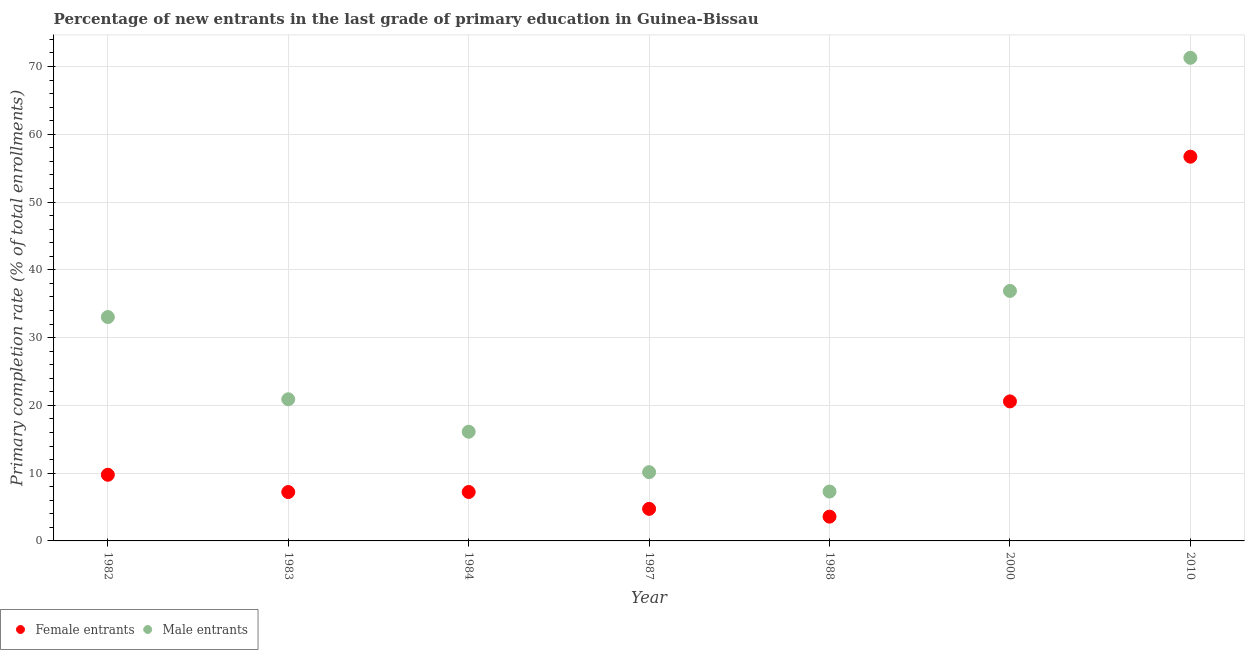How many different coloured dotlines are there?
Offer a very short reply. 2. What is the primary completion rate of female entrants in 1988?
Ensure brevity in your answer.  3.58. Across all years, what is the maximum primary completion rate of female entrants?
Offer a very short reply. 56.69. Across all years, what is the minimum primary completion rate of male entrants?
Your answer should be very brief. 7.28. What is the total primary completion rate of female entrants in the graph?
Keep it short and to the point. 109.78. What is the difference between the primary completion rate of female entrants in 1983 and that in 1988?
Ensure brevity in your answer.  3.63. What is the difference between the primary completion rate of male entrants in 1982 and the primary completion rate of female entrants in 1984?
Provide a succinct answer. 25.81. What is the average primary completion rate of female entrants per year?
Your answer should be compact. 15.68. In the year 1988, what is the difference between the primary completion rate of male entrants and primary completion rate of female entrants?
Provide a short and direct response. 3.7. In how many years, is the primary completion rate of male entrants greater than 58 %?
Keep it short and to the point. 1. What is the ratio of the primary completion rate of female entrants in 1983 to that in 1987?
Offer a terse response. 1.52. What is the difference between the highest and the second highest primary completion rate of male entrants?
Provide a short and direct response. 34.39. What is the difference between the highest and the lowest primary completion rate of male entrants?
Give a very brief answer. 63.99. Is the sum of the primary completion rate of female entrants in 1987 and 2000 greater than the maximum primary completion rate of male entrants across all years?
Provide a succinct answer. No. Is the primary completion rate of female entrants strictly less than the primary completion rate of male entrants over the years?
Keep it short and to the point. Yes. How many years are there in the graph?
Provide a succinct answer. 7. What is the difference between two consecutive major ticks on the Y-axis?
Provide a short and direct response. 10. Are the values on the major ticks of Y-axis written in scientific E-notation?
Provide a succinct answer. No. Does the graph contain grids?
Offer a terse response. Yes. Where does the legend appear in the graph?
Provide a succinct answer. Bottom left. How many legend labels are there?
Ensure brevity in your answer.  2. What is the title of the graph?
Provide a succinct answer. Percentage of new entrants in the last grade of primary education in Guinea-Bissau. What is the label or title of the X-axis?
Ensure brevity in your answer.  Year. What is the label or title of the Y-axis?
Give a very brief answer. Primary completion rate (% of total enrollments). What is the Primary completion rate (% of total enrollments) in Female entrants in 1982?
Your answer should be very brief. 9.76. What is the Primary completion rate (% of total enrollments) of Male entrants in 1982?
Ensure brevity in your answer.  33.03. What is the Primary completion rate (% of total enrollments) in Female entrants in 1983?
Ensure brevity in your answer.  7.21. What is the Primary completion rate (% of total enrollments) of Male entrants in 1983?
Your answer should be very brief. 20.9. What is the Primary completion rate (% of total enrollments) in Female entrants in 1984?
Ensure brevity in your answer.  7.22. What is the Primary completion rate (% of total enrollments) in Male entrants in 1984?
Offer a terse response. 16.11. What is the Primary completion rate (% of total enrollments) of Female entrants in 1987?
Keep it short and to the point. 4.73. What is the Primary completion rate (% of total enrollments) in Male entrants in 1987?
Offer a terse response. 10.14. What is the Primary completion rate (% of total enrollments) of Female entrants in 1988?
Your answer should be very brief. 3.58. What is the Primary completion rate (% of total enrollments) in Male entrants in 1988?
Provide a succinct answer. 7.28. What is the Primary completion rate (% of total enrollments) of Female entrants in 2000?
Give a very brief answer. 20.58. What is the Primary completion rate (% of total enrollments) of Male entrants in 2000?
Ensure brevity in your answer.  36.88. What is the Primary completion rate (% of total enrollments) in Female entrants in 2010?
Keep it short and to the point. 56.69. What is the Primary completion rate (% of total enrollments) of Male entrants in 2010?
Provide a succinct answer. 71.27. Across all years, what is the maximum Primary completion rate (% of total enrollments) in Female entrants?
Offer a terse response. 56.69. Across all years, what is the maximum Primary completion rate (% of total enrollments) of Male entrants?
Keep it short and to the point. 71.27. Across all years, what is the minimum Primary completion rate (% of total enrollments) of Female entrants?
Provide a succinct answer. 3.58. Across all years, what is the minimum Primary completion rate (% of total enrollments) of Male entrants?
Your answer should be very brief. 7.28. What is the total Primary completion rate (% of total enrollments) in Female entrants in the graph?
Your response must be concise. 109.78. What is the total Primary completion rate (% of total enrollments) of Male entrants in the graph?
Give a very brief answer. 195.62. What is the difference between the Primary completion rate (% of total enrollments) in Female entrants in 1982 and that in 1983?
Provide a succinct answer. 2.55. What is the difference between the Primary completion rate (% of total enrollments) in Male entrants in 1982 and that in 1983?
Ensure brevity in your answer.  12.13. What is the difference between the Primary completion rate (% of total enrollments) in Female entrants in 1982 and that in 1984?
Offer a terse response. 2.54. What is the difference between the Primary completion rate (% of total enrollments) of Male entrants in 1982 and that in 1984?
Offer a terse response. 16.92. What is the difference between the Primary completion rate (% of total enrollments) in Female entrants in 1982 and that in 1987?
Make the answer very short. 5.03. What is the difference between the Primary completion rate (% of total enrollments) in Male entrants in 1982 and that in 1987?
Offer a very short reply. 22.89. What is the difference between the Primary completion rate (% of total enrollments) of Female entrants in 1982 and that in 1988?
Your answer should be compact. 6.18. What is the difference between the Primary completion rate (% of total enrollments) in Male entrants in 1982 and that in 1988?
Make the answer very short. 25.74. What is the difference between the Primary completion rate (% of total enrollments) in Female entrants in 1982 and that in 2000?
Make the answer very short. -10.82. What is the difference between the Primary completion rate (% of total enrollments) in Male entrants in 1982 and that in 2000?
Keep it short and to the point. -3.86. What is the difference between the Primary completion rate (% of total enrollments) in Female entrants in 1982 and that in 2010?
Provide a succinct answer. -46.93. What is the difference between the Primary completion rate (% of total enrollments) in Male entrants in 1982 and that in 2010?
Provide a short and direct response. -38.25. What is the difference between the Primary completion rate (% of total enrollments) of Female entrants in 1983 and that in 1984?
Your answer should be compact. -0.01. What is the difference between the Primary completion rate (% of total enrollments) of Male entrants in 1983 and that in 1984?
Make the answer very short. 4.79. What is the difference between the Primary completion rate (% of total enrollments) in Female entrants in 1983 and that in 1987?
Your answer should be compact. 2.48. What is the difference between the Primary completion rate (% of total enrollments) in Male entrants in 1983 and that in 1987?
Provide a succinct answer. 10.76. What is the difference between the Primary completion rate (% of total enrollments) of Female entrants in 1983 and that in 1988?
Give a very brief answer. 3.63. What is the difference between the Primary completion rate (% of total enrollments) in Male entrants in 1983 and that in 1988?
Your answer should be very brief. 13.61. What is the difference between the Primary completion rate (% of total enrollments) in Female entrants in 1983 and that in 2000?
Provide a short and direct response. -13.37. What is the difference between the Primary completion rate (% of total enrollments) of Male entrants in 1983 and that in 2000?
Provide a short and direct response. -15.99. What is the difference between the Primary completion rate (% of total enrollments) of Female entrants in 1983 and that in 2010?
Keep it short and to the point. -49.48. What is the difference between the Primary completion rate (% of total enrollments) in Male entrants in 1983 and that in 2010?
Ensure brevity in your answer.  -50.38. What is the difference between the Primary completion rate (% of total enrollments) of Female entrants in 1984 and that in 1987?
Your answer should be compact. 2.49. What is the difference between the Primary completion rate (% of total enrollments) of Male entrants in 1984 and that in 1987?
Offer a very short reply. 5.97. What is the difference between the Primary completion rate (% of total enrollments) of Female entrants in 1984 and that in 1988?
Give a very brief answer. 3.64. What is the difference between the Primary completion rate (% of total enrollments) of Male entrants in 1984 and that in 1988?
Ensure brevity in your answer.  8.82. What is the difference between the Primary completion rate (% of total enrollments) in Female entrants in 1984 and that in 2000?
Give a very brief answer. -13.37. What is the difference between the Primary completion rate (% of total enrollments) in Male entrants in 1984 and that in 2000?
Ensure brevity in your answer.  -20.78. What is the difference between the Primary completion rate (% of total enrollments) in Female entrants in 1984 and that in 2010?
Ensure brevity in your answer.  -49.47. What is the difference between the Primary completion rate (% of total enrollments) in Male entrants in 1984 and that in 2010?
Offer a terse response. -55.17. What is the difference between the Primary completion rate (% of total enrollments) in Female entrants in 1987 and that in 1988?
Provide a short and direct response. 1.15. What is the difference between the Primary completion rate (% of total enrollments) in Male entrants in 1987 and that in 1988?
Your response must be concise. 2.86. What is the difference between the Primary completion rate (% of total enrollments) in Female entrants in 1987 and that in 2000?
Provide a succinct answer. -15.85. What is the difference between the Primary completion rate (% of total enrollments) in Male entrants in 1987 and that in 2000?
Keep it short and to the point. -26.74. What is the difference between the Primary completion rate (% of total enrollments) in Female entrants in 1987 and that in 2010?
Your response must be concise. -51.96. What is the difference between the Primary completion rate (% of total enrollments) in Male entrants in 1987 and that in 2010?
Give a very brief answer. -61.13. What is the difference between the Primary completion rate (% of total enrollments) of Female entrants in 1988 and that in 2000?
Offer a very short reply. -17. What is the difference between the Primary completion rate (% of total enrollments) in Male entrants in 1988 and that in 2000?
Give a very brief answer. -29.6. What is the difference between the Primary completion rate (% of total enrollments) of Female entrants in 1988 and that in 2010?
Your answer should be compact. -53.11. What is the difference between the Primary completion rate (% of total enrollments) in Male entrants in 1988 and that in 2010?
Your answer should be very brief. -63.99. What is the difference between the Primary completion rate (% of total enrollments) of Female entrants in 2000 and that in 2010?
Your response must be concise. -36.1. What is the difference between the Primary completion rate (% of total enrollments) of Male entrants in 2000 and that in 2010?
Provide a succinct answer. -34.39. What is the difference between the Primary completion rate (% of total enrollments) of Female entrants in 1982 and the Primary completion rate (% of total enrollments) of Male entrants in 1983?
Your answer should be compact. -11.14. What is the difference between the Primary completion rate (% of total enrollments) in Female entrants in 1982 and the Primary completion rate (% of total enrollments) in Male entrants in 1984?
Provide a short and direct response. -6.35. What is the difference between the Primary completion rate (% of total enrollments) in Female entrants in 1982 and the Primary completion rate (% of total enrollments) in Male entrants in 1987?
Provide a short and direct response. -0.38. What is the difference between the Primary completion rate (% of total enrollments) of Female entrants in 1982 and the Primary completion rate (% of total enrollments) of Male entrants in 1988?
Ensure brevity in your answer.  2.48. What is the difference between the Primary completion rate (% of total enrollments) in Female entrants in 1982 and the Primary completion rate (% of total enrollments) in Male entrants in 2000?
Keep it short and to the point. -27.12. What is the difference between the Primary completion rate (% of total enrollments) in Female entrants in 1982 and the Primary completion rate (% of total enrollments) in Male entrants in 2010?
Ensure brevity in your answer.  -61.51. What is the difference between the Primary completion rate (% of total enrollments) in Female entrants in 1983 and the Primary completion rate (% of total enrollments) in Male entrants in 1984?
Make the answer very short. -8.9. What is the difference between the Primary completion rate (% of total enrollments) in Female entrants in 1983 and the Primary completion rate (% of total enrollments) in Male entrants in 1987?
Offer a very short reply. -2.93. What is the difference between the Primary completion rate (% of total enrollments) in Female entrants in 1983 and the Primary completion rate (% of total enrollments) in Male entrants in 1988?
Provide a succinct answer. -0.07. What is the difference between the Primary completion rate (% of total enrollments) of Female entrants in 1983 and the Primary completion rate (% of total enrollments) of Male entrants in 2000?
Provide a short and direct response. -29.67. What is the difference between the Primary completion rate (% of total enrollments) in Female entrants in 1983 and the Primary completion rate (% of total enrollments) in Male entrants in 2010?
Give a very brief answer. -64.06. What is the difference between the Primary completion rate (% of total enrollments) in Female entrants in 1984 and the Primary completion rate (% of total enrollments) in Male entrants in 1987?
Your answer should be compact. -2.92. What is the difference between the Primary completion rate (% of total enrollments) in Female entrants in 1984 and the Primary completion rate (% of total enrollments) in Male entrants in 1988?
Your answer should be compact. -0.07. What is the difference between the Primary completion rate (% of total enrollments) of Female entrants in 1984 and the Primary completion rate (% of total enrollments) of Male entrants in 2000?
Make the answer very short. -29.67. What is the difference between the Primary completion rate (% of total enrollments) in Female entrants in 1984 and the Primary completion rate (% of total enrollments) in Male entrants in 2010?
Your answer should be very brief. -64.05. What is the difference between the Primary completion rate (% of total enrollments) in Female entrants in 1987 and the Primary completion rate (% of total enrollments) in Male entrants in 1988?
Provide a short and direct response. -2.55. What is the difference between the Primary completion rate (% of total enrollments) of Female entrants in 1987 and the Primary completion rate (% of total enrollments) of Male entrants in 2000?
Offer a very short reply. -32.15. What is the difference between the Primary completion rate (% of total enrollments) of Female entrants in 1987 and the Primary completion rate (% of total enrollments) of Male entrants in 2010?
Keep it short and to the point. -66.54. What is the difference between the Primary completion rate (% of total enrollments) in Female entrants in 1988 and the Primary completion rate (% of total enrollments) in Male entrants in 2000?
Offer a very short reply. -33.3. What is the difference between the Primary completion rate (% of total enrollments) of Female entrants in 1988 and the Primary completion rate (% of total enrollments) of Male entrants in 2010?
Offer a very short reply. -67.69. What is the difference between the Primary completion rate (% of total enrollments) of Female entrants in 2000 and the Primary completion rate (% of total enrollments) of Male entrants in 2010?
Your response must be concise. -50.69. What is the average Primary completion rate (% of total enrollments) of Female entrants per year?
Ensure brevity in your answer.  15.68. What is the average Primary completion rate (% of total enrollments) in Male entrants per year?
Your answer should be very brief. 27.95. In the year 1982, what is the difference between the Primary completion rate (% of total enrollments) in Female entrants and Primary completion rate (% of total enrollments) in Male entrants?
Offer a very short reply. -23.27. In the year 1983, what is the difference between the Primary completion rate (% of total enrollments) in Female entrants and Primary completion rate (% of total enrollments) in Male entrants?
Provide a short and direct response. -13.69. In the year 1984, what is the difference between the Primary completion rate (% of total enrollments) of Female entrants and Primary completion rate (% of total enrollments) of Male entrants?
Keep it short and to the point. -8.89. In the year 1987, what is the difference between the Primary completion rate (% of total enrollments) of Female entrants and Primary completion rate (% of total enrollments) of Male entrants?
Offer a very short reply. -5.41. In the year 1988, what is the difference between the Primary completion rate (% of total enrollments) of Female entrants and Primary completion rate (% of total enrollments) of Male entrants?
Your answer should be compact. -3.7. In the year 2000, what is the difference between the Primary completion rate (% of total enrollments) in Female entrants and Primary completion rate (% of total enrollments) in Male entrants?
Your response must be concise. -16.3. In the year 2010, what is the difference between the Primary completion rate (% of total enrollments) of Female entrants and Primary completion rate (% of total enrollments) of Male entrants?
Keep it short and to the point. -14.59. What is the ratio of the Primary completion rate (% of total enrollments) of Female entrants in 1982 to that in 1983?
Your answer should be very brief. 1.35. What is the ratio of the Primary completion rate (% of total enrollments) of Male entrants in 1982 to that in 1983?
Provide a succinct answer. 1.58. What is the ratio of the Primary completion rate (% of total enrollments) of Female entrants in 1982 to that in 1984?
Give a very brief answer. 1.35. What is the ratio of the Primary completion rate (% of total enrollments) of Male entrants in 1982 to that in 1984?
Provide a short and direct response. 2.05. What is the ratio of the Primary completion rate (% of total enrollments) in Female entrants in 1982 to that in 1987?
Keep it short and to the point. 2.06. What is the ratio of the Primary completion rate (% of total enrollments) in Male entrants in 1982 to that in 1987?
Offer a terse response. 3.26. What is the ratio of the Primary completion rate (% of total enrollments) in Female entrants in 1982 to that in 1988?
Provide a short and direct response. 2.73. What is the ratio of the Primary completion rate (% of total enrollments) in Male entrants in 1982 to that in 1988?
Keep it short and to the point. 4.53. What is the ratio of the Primary completion rate (% of total enrollments) of Female entrants in 1982 to that in 2000?
Provide a short and direct response. 0.47. What is the ratio of the Primary completion rate (% of total enrollments) of Male entrants in 1982 to that in 2000?
Offer a terse response. 0.9. What is the ratio of the Primary completion rate (% of total enrollments) of Female entrants in 1982 to that in 2010?
Provide a short and direct response. 0.17. What is the ratio of the Primary completion rate (% of total enrollments) in Male entrants in 1982 to that in 2010?
Give a very brief answer. 0.46. What is the ratio of the Primary completion rate (% of total enrollments) of Male entrants in 1983 to that in 1984?
Make the answer very short. 1.3. What is the ratio of the Primary completion rate (% of total enrollments) in Female entrants in 1983 to that in 1987?
Your answer should be very brief. 1.52. What is the ratio of the Primary completion rate (% of total enrollments) in Male entrants in 1983 to that in 1987?
Your answer should be very brief. 2.06. What is the ratio of the Primary completion rate (% of total enrollments) in Female entrants in 1983 to that in 1988?
Your response must be concise. 2.01. What is the ratio of the Primary completion rate (% of total enrollments) in Male entrants in 1983 to that in 1988?
Keep it short and to the point. 2.87. What is the ratio of the Primary completion rate (% of total enrollments) of Female entrants in 1983 to that in 2000?
Provide a short and direct response. 0.35. What is the ratio of the Primary completion rate (% of total enrollments) of Male entrants in 1983 to that in 2000?
Make the answer very short. 0.57. What is the ratio of the Primary completion rate (% of total enrollments) in Female entrants in 1983 to that in 2010?
Offer a terse response. 0.13. What is the ratio of the Primary completion rate (% of total enrollments) in Male entrants in 1983 to that in 2010?
Your answer should be compact. 0.29. What is the ratio of the Primary completion rate (% of total enrollments) of Female entrants in 1984 to that in 1987?
Your answer should be very brief. 1.53. What is the ratio of the Primary completion rate (% of total enrollments) of Male entrants in 1984 to that in 1987?
Offer a terse response. 1.59. What is the ratio of the Primary completion rate (% of total enrollments) of Female entrants in 1984 to that in 1988?
Ensure brevity in your answer.  2.02. What is the ratio of the Primary completion rate (% of total enrollments) in Male entrants in 1984 to that in 1988?
Offer a terse response. 2.21. What is the ratio of the Primary completion rate (% of total enrollments) in Female entrants in 1984 to that in 2000?
Offer a terse response. 0.35. What is the ratio of the Primary completion rate (% of total enrollments) of Male entrants in 1984 to that in 2000?
Give a very brief answer. 0.44. What is the ratio of the Primary completion rate (% of total enrollments) of Female entrants in 1984 to that in 2010?
Your response must be concise. 0.13. What is the ratio of the Primary completion rate (% of total enrollments) of Male entrants in 1984 to that in 2010?
Provide a short and direct response. 0.23. What is the ratio of the Primary completion rate (% of total enrollments) of Female entrants in 1987 to that in 1988?
Your answer should be compact. 1.32. What is the ratio of the Primary completion rate (% of total enrollments) of Male entrants in 1987 to that in 1988?
Offer a terse response. 1.39. What is the ratio of the Primary completion rate (% of total enrollments) of Female entrants in 1987 to that in 2000?
Make the answer very short. 0.23. What is the ratio of the Primary completion rate (% of total enrollments) of Male entrants in 1987 to that in 2000?
Make the answer very short. 0.28. What is the ratio of the Primary completion rate (% of total enrollments) in Female entrants in 1987 to that in 2010?
Provide a short and direct response. 0.08. What is the ratio of the Primary completion rate (% of total enrollments) of Male entrants in 1987 to that in 2010?
Your answer should be compact. 0.14. What is the ratio of the Primary completion rate (% of total enrollments) of Female entrants in 1988 to that in 2000?
Offer a terse response. 0.17. What is the ratio of the Primary completion rate (% of total enrollments) in Male entrants in 1988 to that in 2000?
Provide a short and direct response. 0.2. What is the ratio of the Primary completion rate (% of total enrollments) of Female entrants in 1988 to that in 2010?
Offer a very short reply. 0.06. What is the ratio of the Primary completion rate (% of total enrollments) in Male entrants in 1988 to that in 2010?
Your answer should be compact. 0.1. What is the ratio of the Primary completion rate (% of total enrollments) of Female entrants in 2000 to that in 2010?
Offer a terse response. 0.36. What is the ratio of the Primary completion rate (% of total enrollments) of Male entrants in 2000 to that in 2010?
Your response must be concise. 0.52. What is the difference between the highest and the second highest Primary completion rate (% of total enrollments) in Female entrants?
Offer a very short reply. 36.1. What is the difference between the highest and the second highest Primary completion rate (% of total enrollments) of Male entrants?
Ensure brevity in your answer.  34.39. What is the difference between the highest and the lowest Primary completion rate (% of total enrollments) of Female entrants?
Give a very brief answer. 53.11. What is the difference between the highest and the lowest Primary completion rate (% of total enrollments) of Male entrants?
Offer a very short reply. 63.99. 